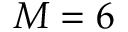Convert formula to latex. <formula><loc_0><loc_0><loc_500><loc_500>M = 6</formula> 